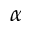Convert formula to latex. <formula><loc_0><loc_0><loc_500><loc_500>\alpha</formula> 